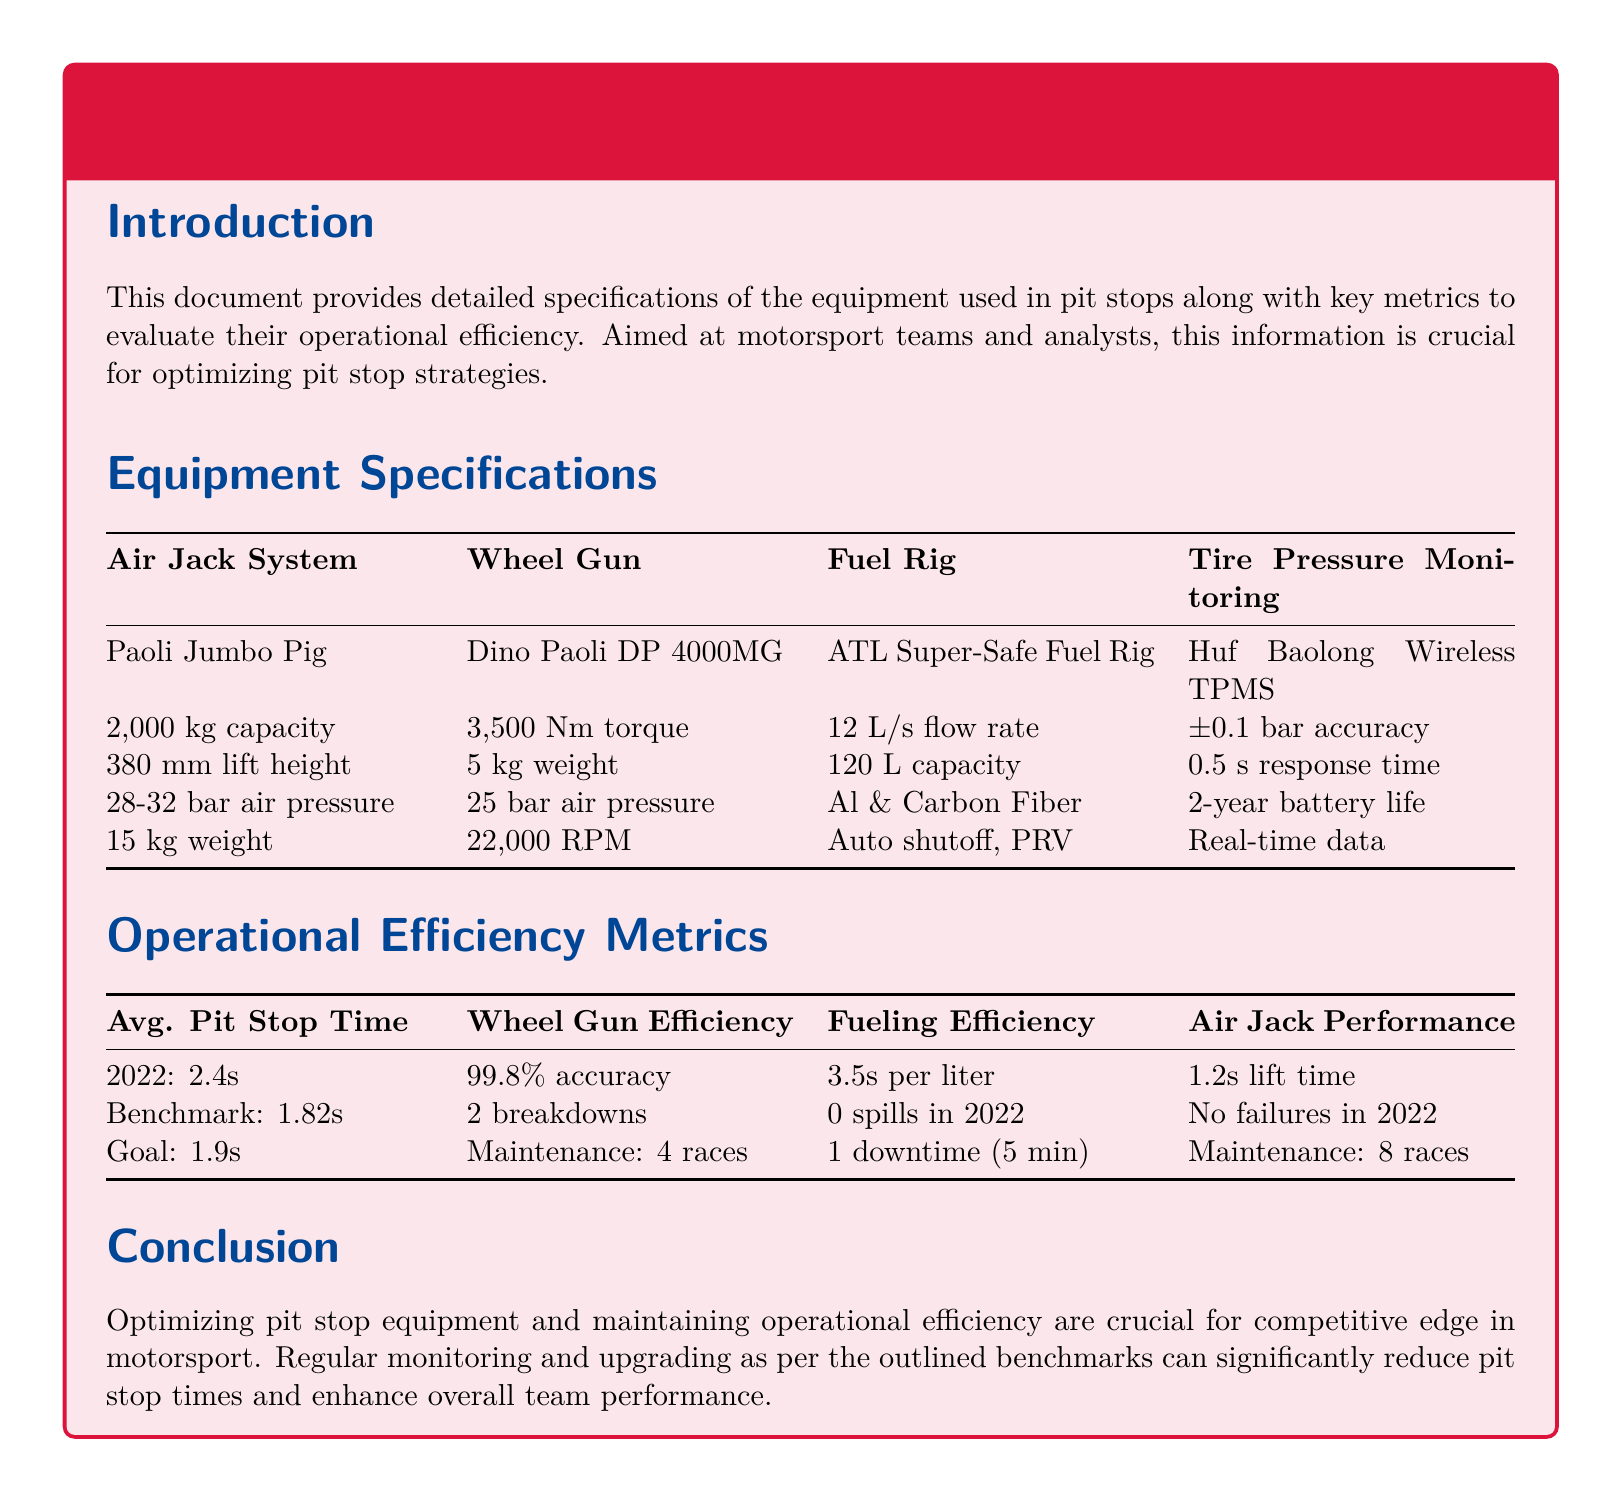What is the capacity of the Air Jack System? The capacity of the Air Jack System is specified in the document as 2,000 kg.
Answer: 2,000 kg What is the torque of the Wheel Gun? The torque of the Wheel Gun is stated as 3,500 Nm in the equipment specifications.
Answer: 3,500 Nm What is the average pit stop time in 2022? The average pit stop time for the year 2022 is provided as 2.4 seconds.
Answer: 2.4s What is the downtime for fueling efficiency? The document mentions a downtime of 5 minutes concerning fueling efficiency.
Answer: 5 min What is the lift time performance of the Air Jack? The lift time for the Air Jack performance is listed as 1.2 seconds in the metrics section.
Answer: 1.2s What is the accuracy of the Tire Pressure Monitoring system? The accuracy of the Tire Pressure Monitoring system is ±0.1 bar according to the specifications.
Answer: ±0.1 bar What benchmark is set for the average pit stop time? The benchmark set for the average pit stop time is 1.82 seconds.
Answer: 1.82s How many maintenance races are planned for the Wheel Gun? The document indicates that Maintenance for the Wheel Gun is planned for 4 races.
Answer: 4 races What is the goal time for the average pit stop? The goal for the average pit stop time is stated as 1.9 seconds.
Answer: 1.9s 